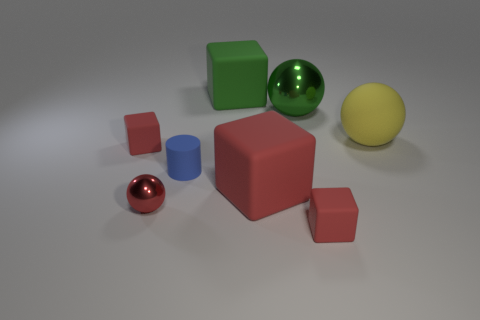Do the objects have any shadows, and if so, what does that tell us about the lighting? Each object has a shadow which indicates that there is a single light source shining from above. The shadows help create a sense of depth and form within the composition. Can you guess the position of the light source based on the shadows? Based on the direction and length of the shadows, the light source appears to be located above and slightly to the left of the center of the scene. 